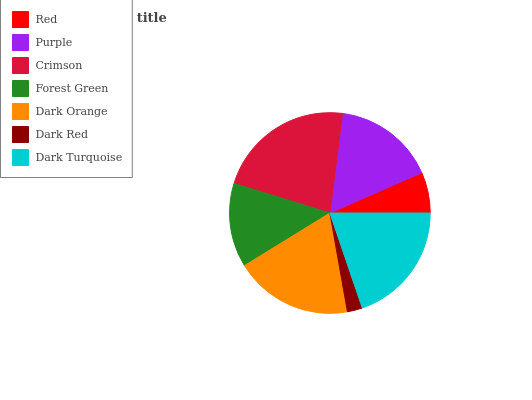Is Dark Red the minimum?
Answer yes or no. Yes. Is Crimson the maximum?
Answer yes or no. Yes. Is Purple the minimum?
Answer yes or no. No. Is Purple the maximum?
Answer yes or no. No. Is Purple greater than Red?
Answer yes or no. Yes. Is Red less than Purple?
Answer yes or no. Yes. Is Red greater than Purple?
Answer yes or no. No. Is Purple less than Red?
Answer yes or no. No. Is Purple the high median?
Answer yes or no. Yes. Is Purple the low median?
Answer yes or no. Yes. Is Crimson the high median?
Answer yes or no. No. Is Forest Green the low median?
Answer yes or no. No. 